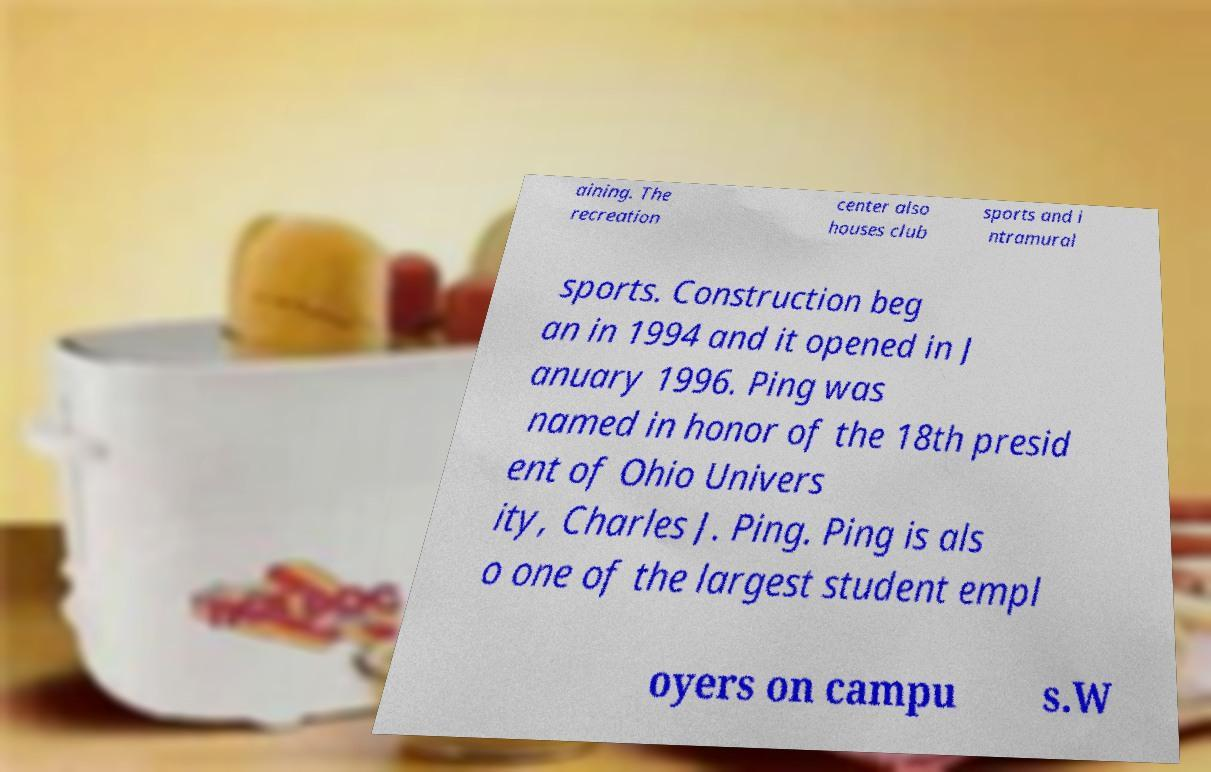For documentation purposes, I need the text within this image transcribed. Could you provide that? aining. The recreation center also houses club sports and i ntramural sports. Construction beg an in 1994 and it opened in J anuary 1996. Ping was named in honor of the 18th presid ent of Ohio Univers ity, Charles J. Ping. Ping is als o one of the largest student empl oyers on campu s.W 